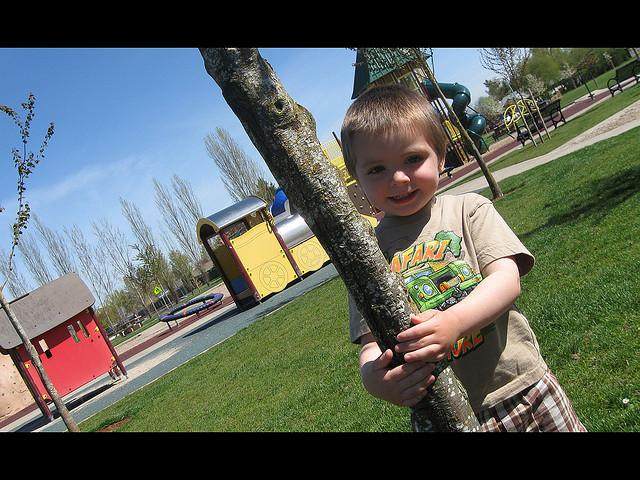At which location does the child hold the tree? playground 